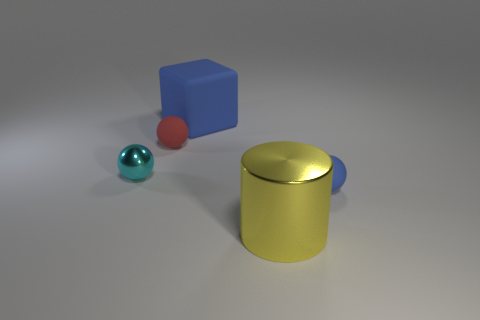Is there a tiny thing of the same color as the cube?
Your answer should be very brief. Yes. How many other things are there of the same material as the large yellow object?
Give a very brief answer. 1. What color is the rubber object that is both in front of the big blue rubber thing and on the left side of the large cylinder?
Keep it short and to the point. Red. The red sphere is what size?
Keep it short and to the point. Small. There is a tiny rubber thing on the right side of the matte cube; is it the same color as the cube?
Keep it short and to the point. Yes. Is the number of small cyan spheres to the left of the small blue rubber object greater than the number of tiny blue objects that are in front of the large yellow cylinder?
Make the answer very short. Yes. Are there more big blue rubber cylinders than yellow cylinders?
Your response must be concise. No. There is a thing that is behind the small shiny object and on the left side of the big rubber cube; what size is it?
Offer a terse response. Small. What is the shape of the cyan thing?
Offer a very short reply. Sphere. Are there more tiny red matte things on the left side of the blue ball than big yellow shiny cubes?
Your answer should be very brief. Yes. 